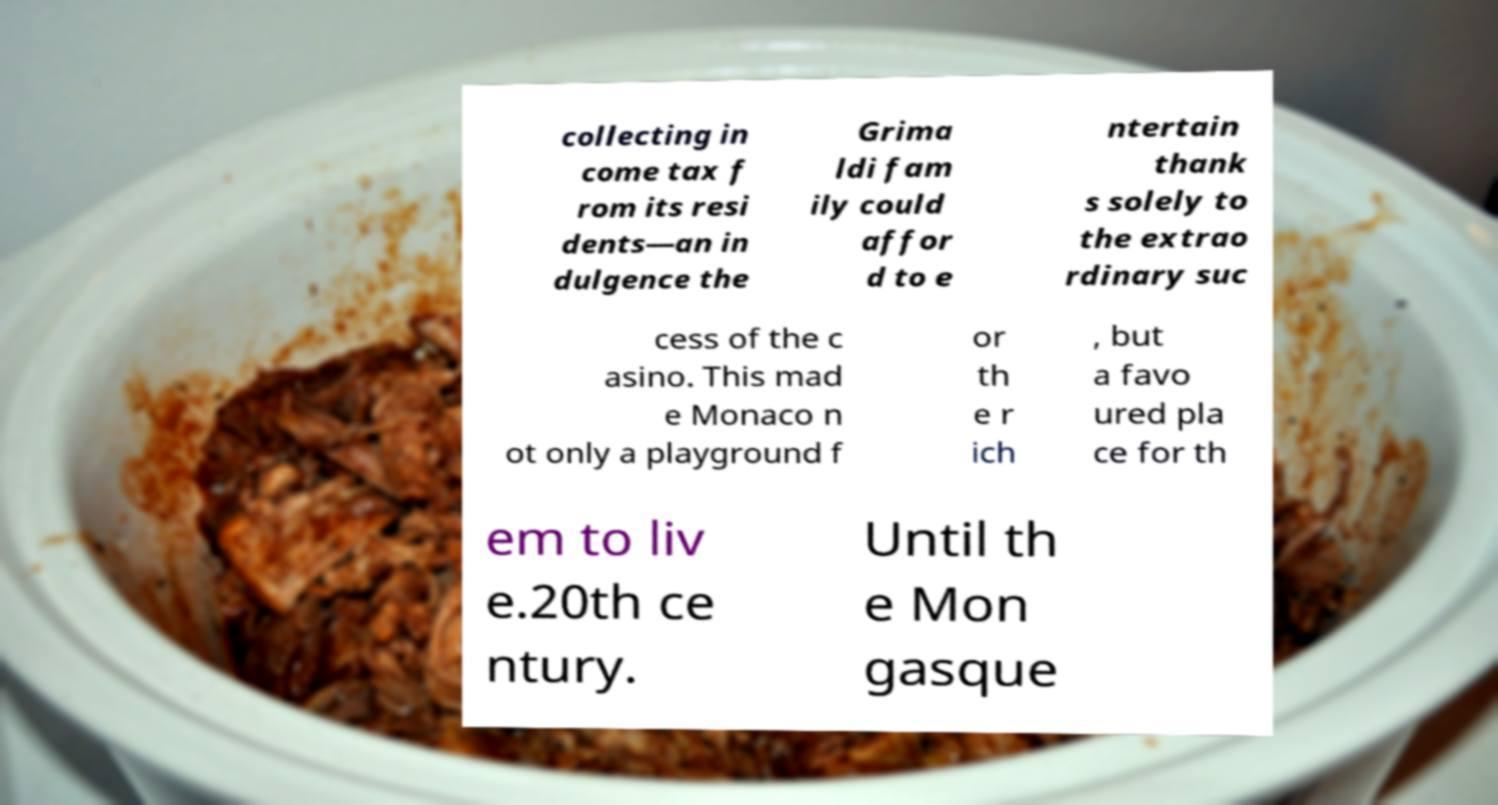I need the written content from this picture converted into text. Can you do that? collecting in come tax f rom its resi dents—an in dulgence the Grima ldi fam ily could affor d to e ntertain thank s solely to the extrao rdinary suc cess of the c asino. This mad e Monaco n ot only a playground f or th e r ich , but a favo ured pla ce for th em to liv e.20th ce ntury. Until th e Mon gasque 